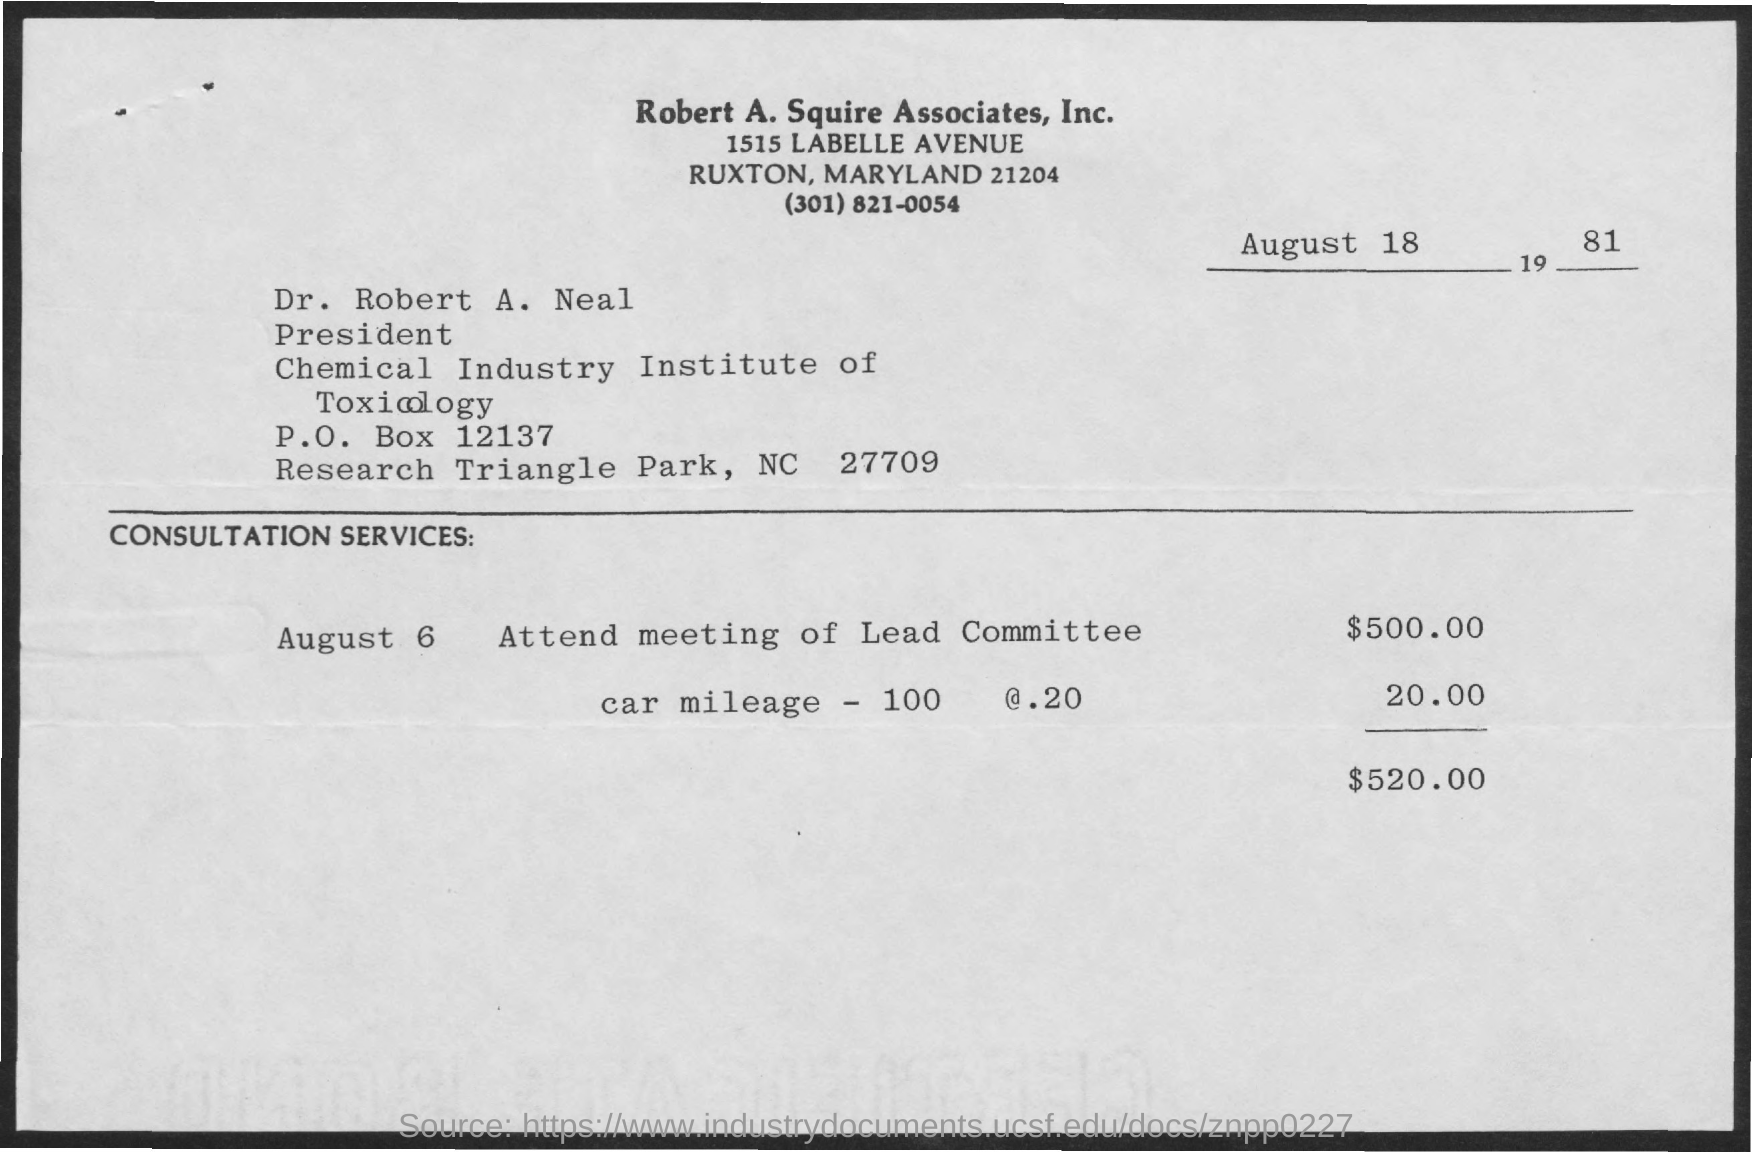Identify some key points in this picture. The P.O. Box is a physical address used to receive mail, typically found at a post office or mail center. The date on the document is August 18, 1981. The letter is addressed to Dr. Robert A. Neal. The amount for car mileage is $20.00, calculated by taking 100 miles and multiplying it by a cost of $.20 per mile. The consultation service fee for attending a meeting of the lead committee is $500.00. 